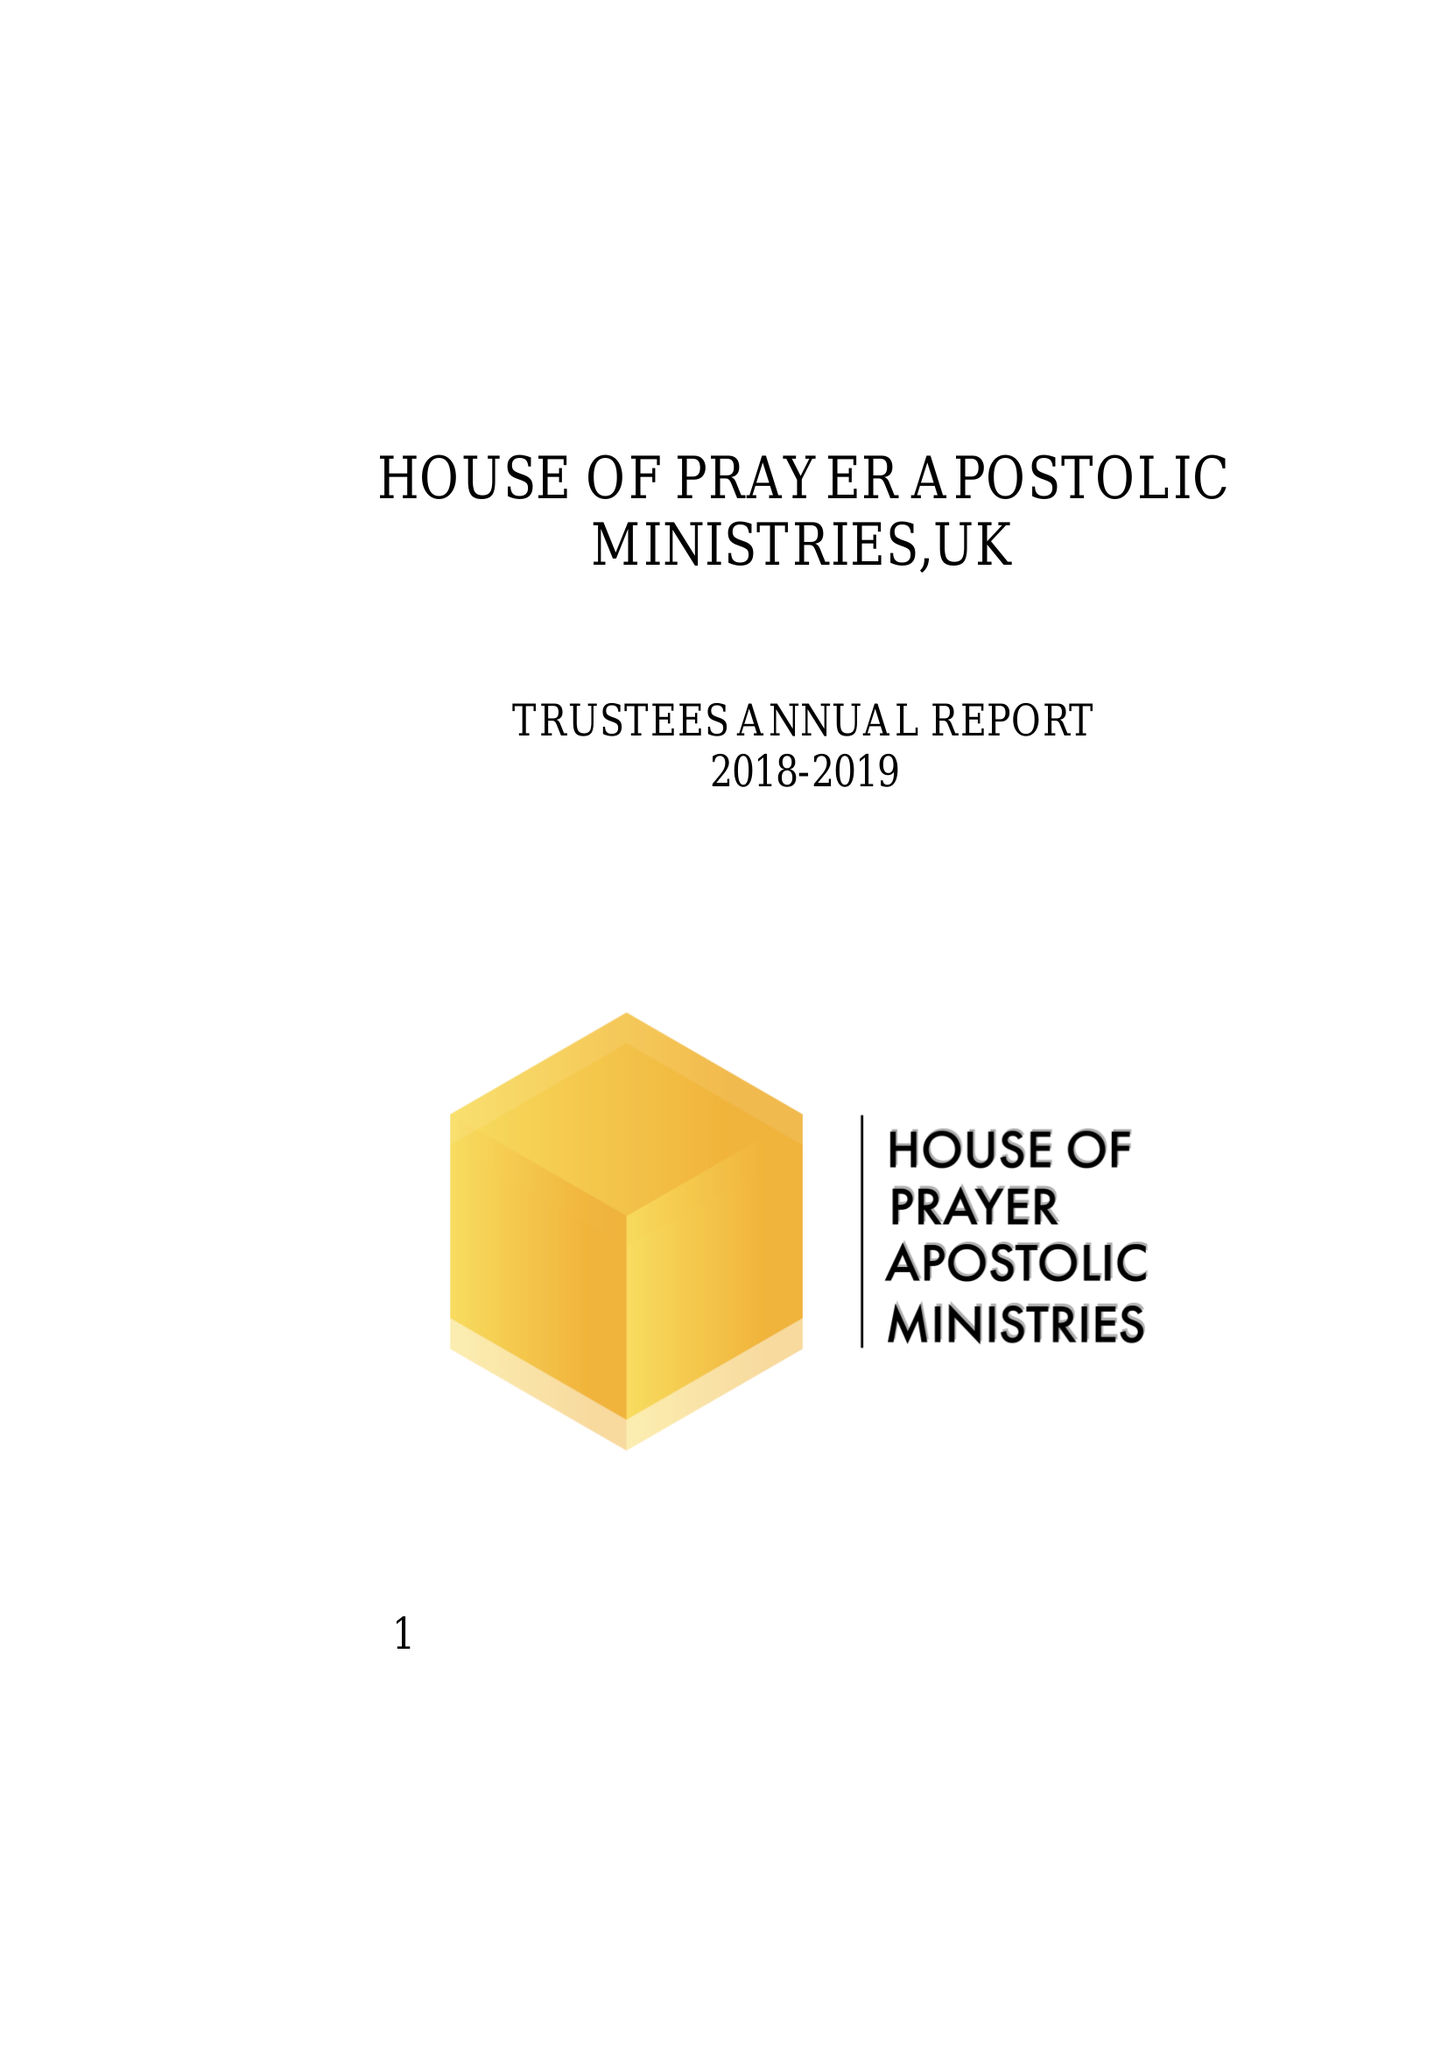What is the value for the address__postcode?
Answer the question using a single word or phrase. DL1 1XF 